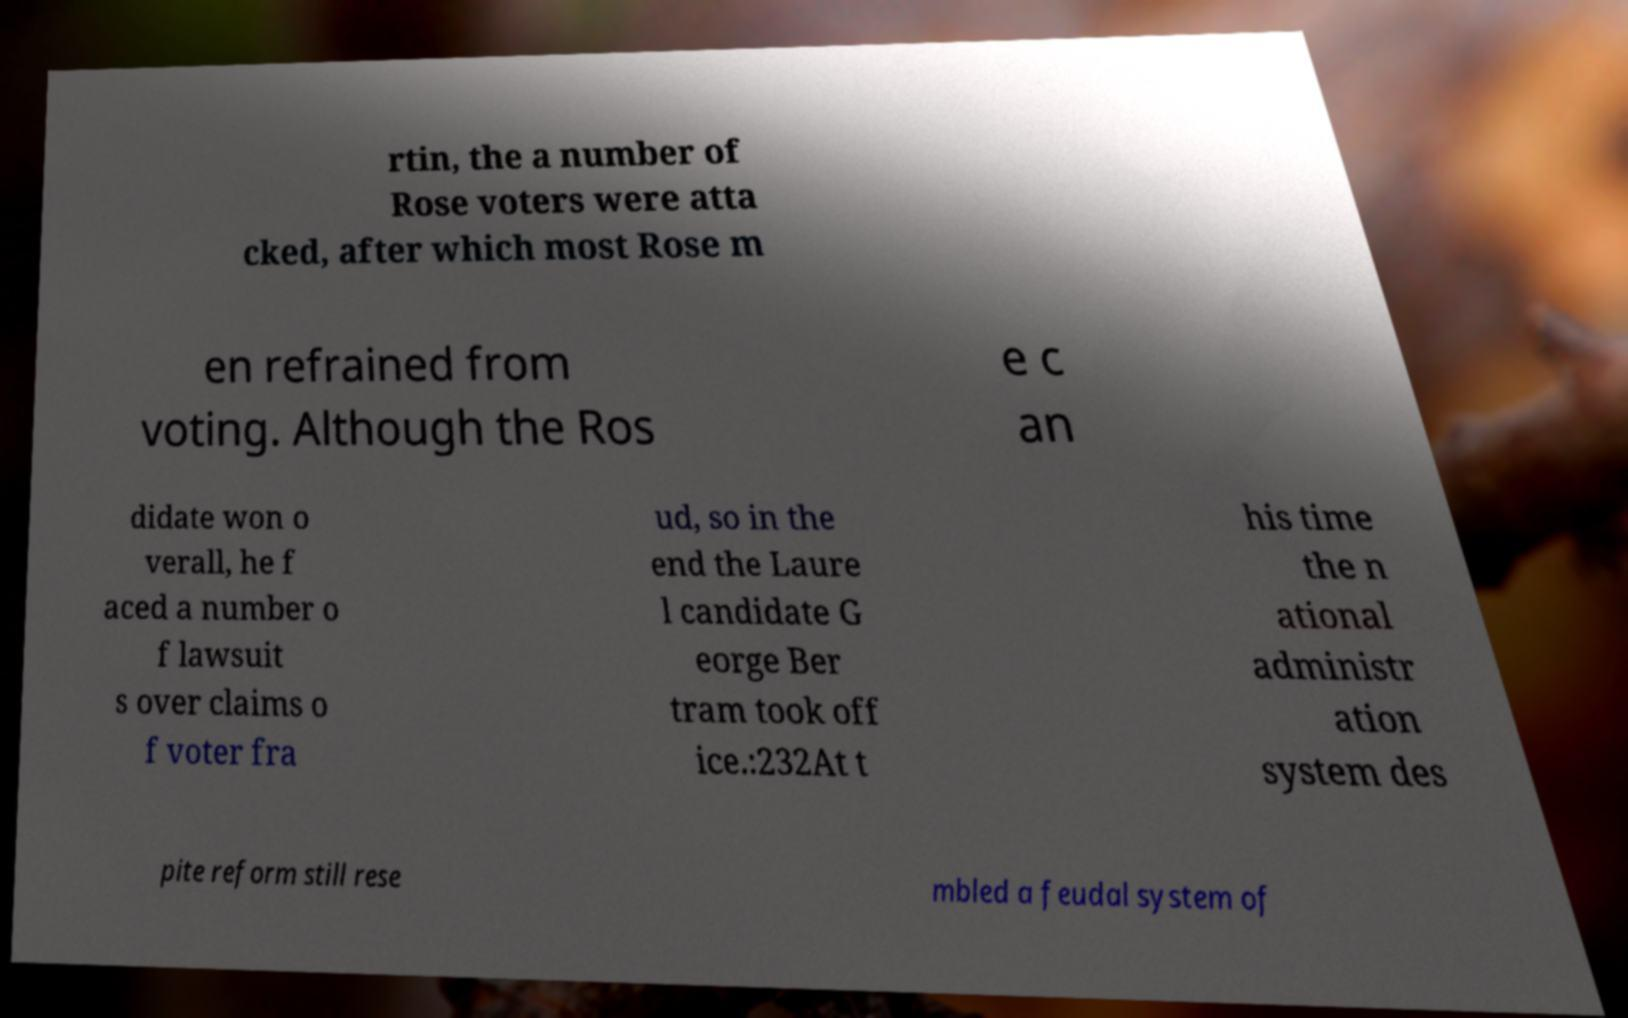For documentation purposes, I need the text within this image transcribed. Could you provide that? rtin, the a number of Rose voters were atta cked, after which most Rose m en refrained from voting. Although the Ros e c an didate won o verall, he f aced a number o f lawsuit s over claims o f voter fra ud, so in the end the Laure l candidate G eorge Ber tram took off ice.:232At t his time the n ational administr ation system des pite reform still rese mbled a feudal system of 